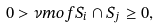Convert formula to latex. <formula><loc_0><loc_0><loc_500><loc_500>0 > \nu m o f { S _ { i } \cap S _ { j } } \geq 0 ,</formula> 